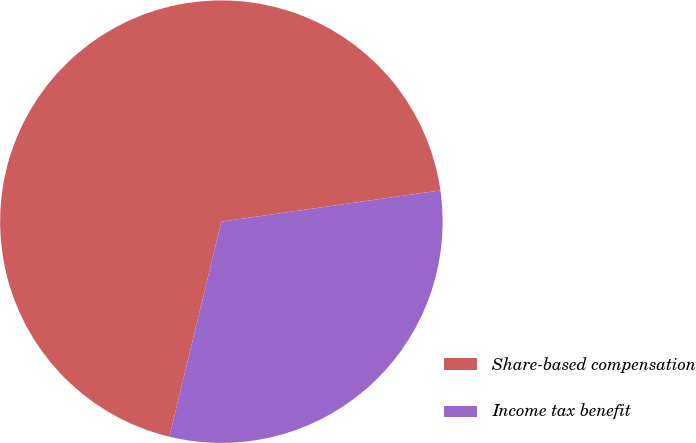Convert chart to OTSL. <chart><loc_0><loc_0><loc_500><loc_500><pie_chart><fcel>Share-based compensation<fcel>Income tax benefit<nl><fcel>68.97%<fcel>31.03%<nl></chart> 